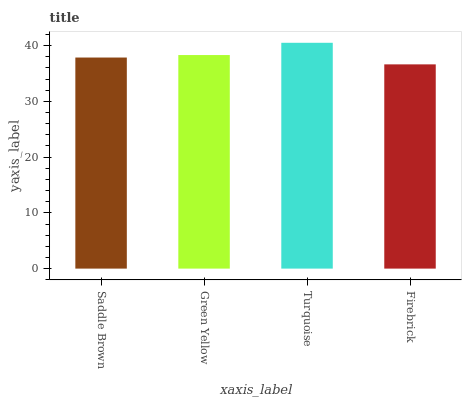Is Firebrick the minimum?
Answer yes or no. Yes. Is Turquoise the maximum?
Answer yes or no. Yes. Is Green Yellow the minimum?
Answer yes or no. No. Is Green Yellow the maximum?
Answer yes or no. No. Is Green Yellow greater than Saddle Brown?
Answer yes or no. Yes. Is Saddle Brown less than Green Yellow?
Answer yes or no. Yes. Is Saddle Brown greater than Green Yellow?
Answer yes or no. No. Is Green Yellow less than Saddle Brown?
Answer yes or no. No. Is Green Yellow the high median?
Answer yes or no. Yes. Is Saddle Brown the low median?
Answer yes or no. Yes. Is Firebrick the high median?
Answer yes or no. No. Is Turquoise the low median?
Answer yes or no. No. 